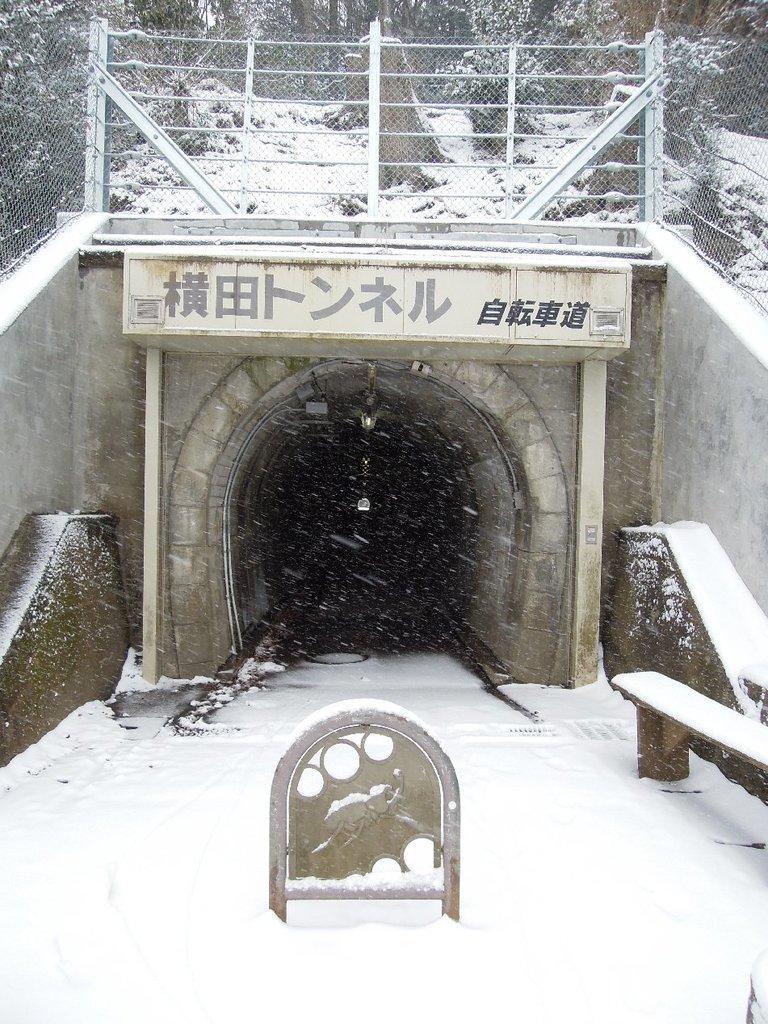Describe this image in one or two sentences. Here we can see a tunnel and there is a name board on it in Chinese language. In the background we can see fence,poles,trees and snow is falling on the ground. At the bottom we can see a bench on the right side and there is an object on the ground. 